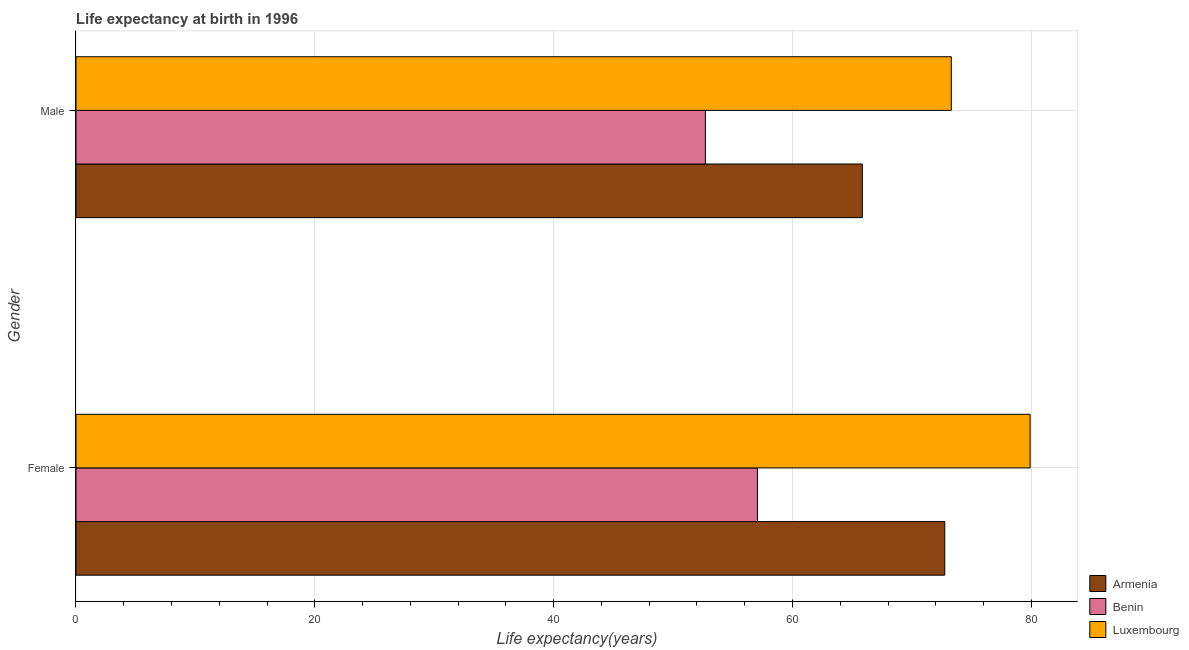How many groups of bars are there?
Offer a terse response. 2. Are the number of bars per tick equal to the number of legend labels?
Provide a succinct answer. Yes. Are the number of bars on each tick of the Y-axis equal?
Provide a succinct answer. Yes. How many bars are there on the 1st tick from the top?
Provide a succinct answer. 3. What is the label of the 1st group of bars from the top?
Give a very brief answer. Male. What is the life expectancy(male) in Armenia?
Ensure brevity in your answer.  65.85. Across all countries, what is the maximum life expectancy(female)?
Your answer should be compact. 79.9. Across all countries, what is the minimum life expectancy(male)?
Provide a short and direct response. 52.7. In which country was the life expectancy(male) maximum?
Your answer should be compact. Luxembourg. In which country was the life expectancy(female) minimum?
Offer a terse response. Benin. What is the total life expectancy(female) in the graph?
Offer a very short reply. 209.72. What is the difference between the life expectancy(male) in Armenia and that in Luxembourg?
Make the answer very short. -7.45. What is the difference between the life expectancy(female) in Benin and the life expectancy(male) in Luxembourg?
Keep it short and to the point. -16.23. What is the average life expectancy(male) per country?
Your answer should be compact. 63.95. What is the difference between the life expectancy(female) and life expectancy(male) in Armenia?
Give a very brief answer. 6.9. In how many countries, is the life expectancy(female) greater than 8 years?
Offer a terse response. 3. What is the ratio of the life expectancy(female) in Armenia to that in Luxembourg?
Make the answer very short. 0.91. Is the life expectancy(male) in Benin less than that in Luxembourg?
Make the answer very short. Yes. In how many countries, is the life expectancy(female) greater than the average life expectancy(female) taken over all countries?
Your response must be concise. 2. What does the 3rd bar from the top in Male represents?
Make the answer very short. Armenia. What does the 3rd bar from the bottom in Male represents?
Make the answer very short. Luxembourg. How many bars are there?
Your answer should be compact. 6. Are all the bars in the graph horizontal?
Keep it short and to the point. Yes. Does the graph contain any zero values?
Give a very brief answer. No. Where does the legend appear in the graph?
Your response must be concise. Bottom right. How many legend labels are there?
Your answer should be compact. 3. How are the legend labels stacked?
Your answer should be very brief. Vertical. What is the title of the graph?
Keep it short and to the point. Life expectancy at birth in 1996. Does "Denmark" appear as one of the legend labels in the graph?
Make the answer very short. No. What is the label or title of the X-axis?
Ensure brevity in your answer.  Life expectancy(years). What is the Life expectancy(years) in Armenia in Female?
Provide a succinct answer. 72.75. What is the Life expectancy(years) of Benin in Female?
Your answer should be very brief. 57.07. What is the Life expectancy(years) of Luxembourg in Female?
Give a very brief answer. 79.9. What is the Life expectancy(years) in Armenia in Male?
Provide a succinct answer. 65.85. What is the Life expectancy(years) in Benin in Male?
Make the answer very short. 52.7. What is the Life expectancy(years) in Luxembourg in Male?
Give a very brief answer. 73.3. Across all Gender, what is the maximum Life expectancy(years) in Armenia?
Offer a terse response. 72.75. Across all Gender, what is the maximum Life expectancy(years) of Benin?
Provide a short and direct response. 57.07. Across all Gender, what is the maximum Life expectancy(years) in Luxembourg?
Make the answer very short. 79.9. Across all Gender, what is the minimum Life expectancy(years) in Armenia?
Give a very brief answer. 65.85. Across all Gender, what is the minimum Life expectancy(years) in Benin?
Give a very brief answer. 52.7. Across all Gender, what is the minimum Life expectancy(years) of Luxembourg?
Offer a terse response. 73.3. What is the total Life expectancy(years) in Armenia in the graph?
Ensure brevity in your answer.  138.6. What is the total Life expectancy(years) in Benin in the graph?
Ensure brevity in your answer.  109.77. What is the total Life expectancy(years) of Luxembourg in the graph?
Your answer should be very brief. 153.2. What is the difference between the Life expectancy(years) in Benin in Female and that in Male?
Provide a short and direct response. 4.36. What is the difference between the Life expectancy(years) of Luxembourg in Female and that in Male?
Your answer should be very brief. 6.6. What is the difference between the Life expectancy(years) of Armenia in Female and the Life expectancy(years) of Benin in Male?
Make the answer very short. 20.05. What is the difference between the Life expectancy(years) in Armenia in Female and the Life expectancy(years) in Luxembourg in Male?
Keep it short and to the point. -0.55. What is the difference between the Life expectancy(years) in Benin in Female and the Life expectancy(years) in Luxembourg in Male?
Offer a very short reply. -16.23. What is the average Life expectancy(years) of Armenia per Gender?
Make the answer very short. 69.3. What is the average Life expectancy(years) in Benin per Gender?
Your answer should be compact. 54.88. What is the average Life expectancy(years) in Luxembourg per Gender?
Give a very brief answer. 76.6. What is the difference between the Life expectancy(years) in Armenia and Life expectancy(years) in Benin in Female?
Your answer should be compact. 15.69. What is the difference between the Life expectancy(years) in Armenia and Life expectancy(years) in Luxembourg in Female?
Offer a terse response. -7.15. What is the difference between the Life expectancy(years) of Benin and Life expectancy(years) of Luxembourg in Female?
Your response must be concise. -22.83. What is the difference between the Life expectancy(years) in Armenia and Life expectancy(years) in Benin in Male?
Offer a very short reply. 13.15. What is the difference between the Life expectancy(years) in Armenia and Life expectancy(years) in Luxembourg in Male?
Provide a succinct answer. -7.45. What is the difference between the Life expectancy(years) of Benin and Life expectancy(years) of Luxembourg in Male?
Your answer should be very brief. -20.6. What is the ratio of the Life expectancy(years) in Armenia in Female to that in Male?
Provide a succinct answer. 1.1. What is the ratio of the Life expectancy(years) of Benin in Female to that in Male?
Ensure brevity in your answer.  1.08. What is the ratio of the Life expectancy(years) in Luxembourg in Female to that in Male?
Your response must be concise. 1.09. What is the difference between the highest and the second highest Life expectancy(years) in Benin?
Your response must be concise. 4.36. What is the difference between the highest and the second highest Life expectancy(years) in Luxembourg?
Keep it short and to the point. 6.6. What is the difference between the highest and the lowest Life expectancy(years) in Benin?
Your answer should be compact. 4.36. What is the difference between the highest and the lowest Life expectancy(years) in Luxembourg?
Your answer should be very brief. 6.6. 